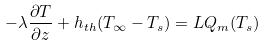<formula> <loc_0><loc_0><loc_500><loc_500>- \lambda \frac { \partial T } { \partial z } + h _ { t h } ( T _ { \infty } - T _ { s } ) = { L } Q _ { m } ( T _ { s } )</formula> 